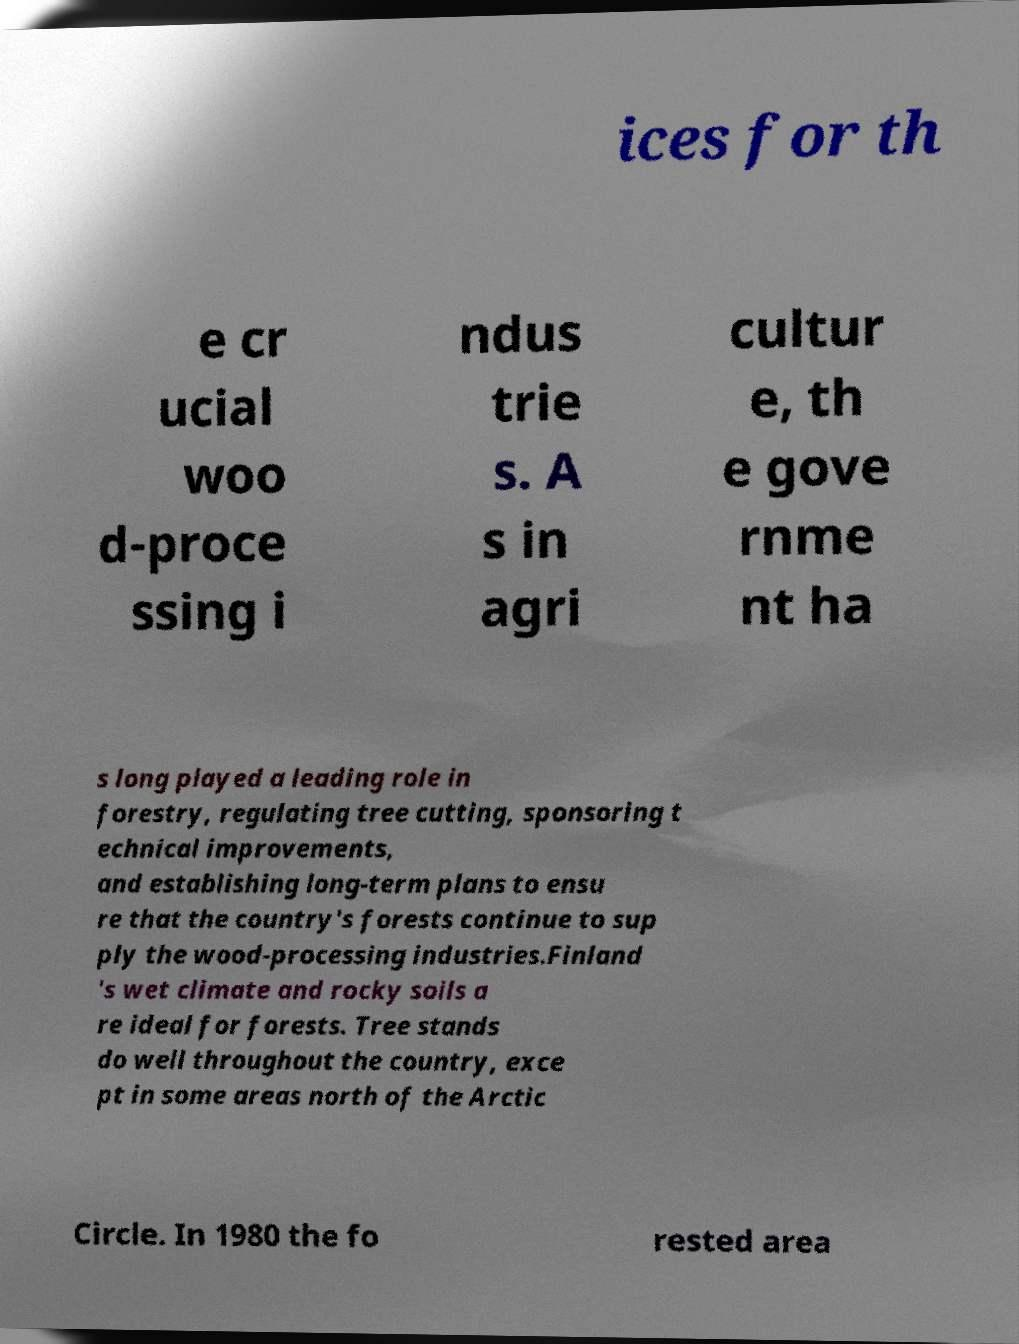Can you read and provide the text displayed in the image?This photo seems to have some interesting text. Can you extract and type it out for me? ices for th e cr ucial woo d-proce ssing i ndus trie s. A s in agri cultur e, th e gove rnme nt ha s long played a leading role in forestry, regulating tree cutting, sponsoring t echnical improvements, and establishing long-term plans to ensu re that the country's forests continue to sup ply the wood-processing industries.Finland 's wet climate and rocky soils a re ideal for forests. Tree stands do well throughout the country, exce pt in some areas north of the Arctic Circle. In 1980 the fo rested area 